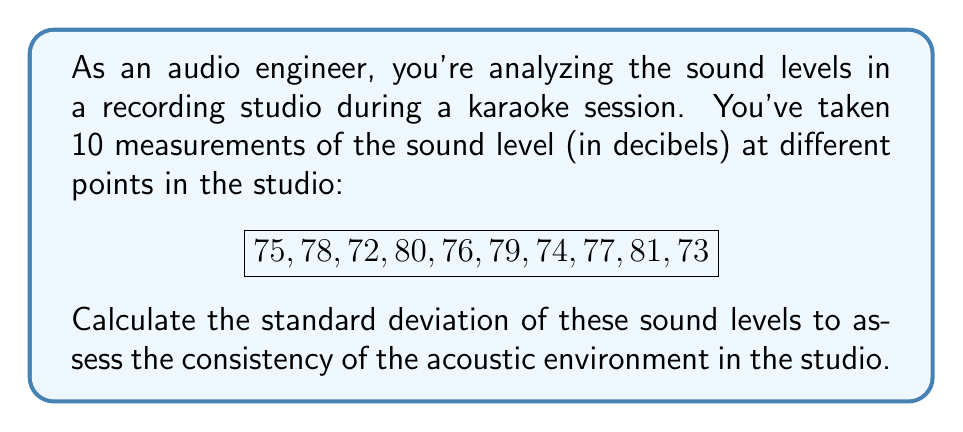Can you solve this math problem? To calculate the standard deviation, we'll follow these steps:

1. Calculate the mean ($\mu$) of the sound levels:
   $$ \mu = \frac{\sum_{i=1}^{n} x_i}{n} = \frac{75 + 78 + 72 + 80 + 76 + 79 + 74 + 77 + 81 + 73}{10} = 76.5 \text{ dB} $$

2. Calculate the squared differences from the mean:
   $$ (75 - 76.5)^2 = 2.25 $$
   $$ (78 - 76.5)^2 = 2.25 $$
   $$ (72 - 76.5)^2 = 20.25 $$
   $$ (80 - 76.5)^2 = 12.25 $$
   $$ (76 - 76.5)^2 = 0.25 $$
   $$ (79 - 76.5)^2 = 6.25 $$
   $$ (74 - 76.5)^2 = 6.25 $$
   $$ (77 - 76.5)^2 = 0.25 $$
   $$ (81 - 76.5)^2 = 20.25 $$
   $$ (73 - 76.5)^2 = 12.25 $$

3. Calculate the sum of squared differences:
   $$ \sum_{i=1}^{n} (x_i - \mu)^2 = 82.5 $$

4. Calculate the variance ($\sigma^2$):
   $$ \sigma^2 = \frac{\sum_{i=1}^{n} (x_i - \mu)^2}{n} = \frac{82.5}{10} = 8.25 $$

5. Calculate the standard deviation ($\sigma$) by taking the square root of the variance:
   $$ \sigma = \sqrt{\sigma^2} = \sqrt{8.25} \approx 2.87 \text{ dB} $$
Answer: The standard deviation of the sound levels in the recording studio is approximately $2.87 \text{ dB}$. 